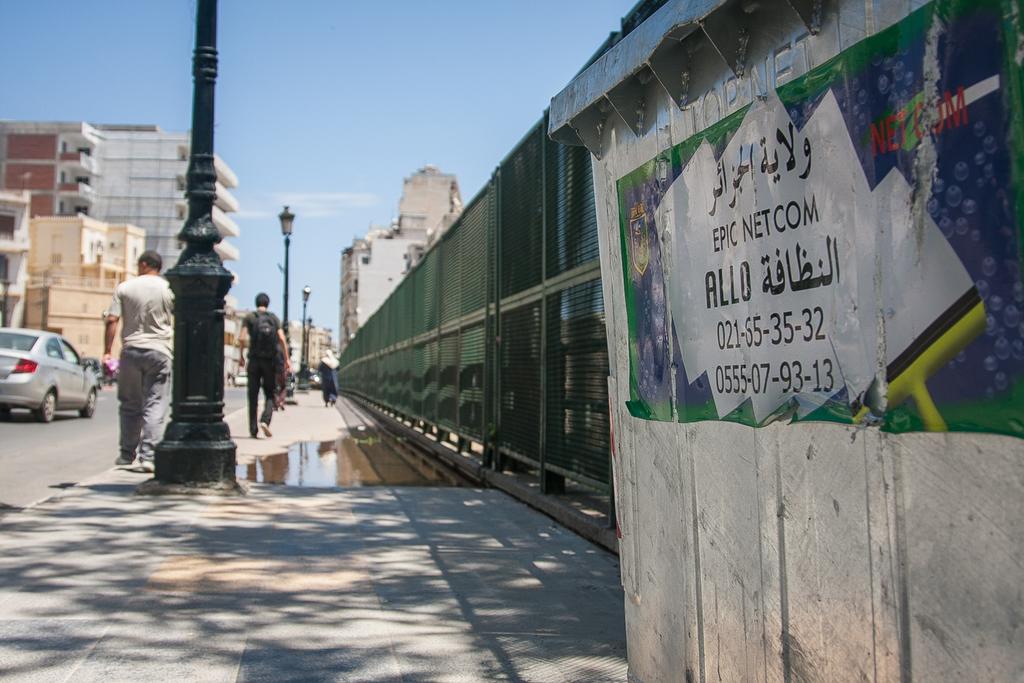What is the phone number on the bottom of the poster?
Your answer should be compact. 0555-07-93-13. Is epic net com a phone company?
Keep it short and to the point. Yes. 